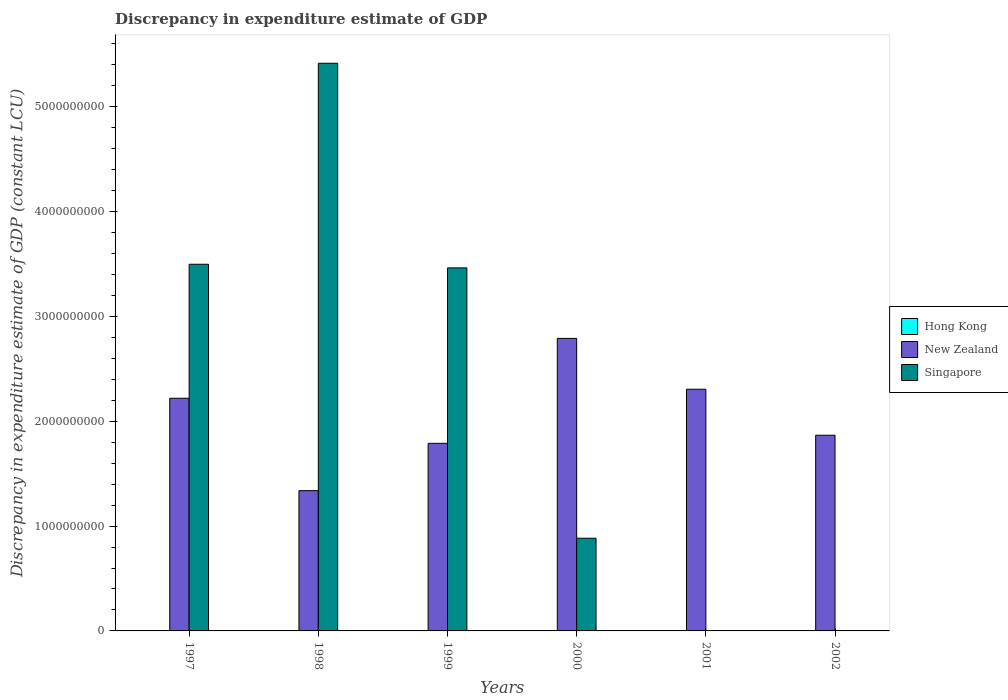How many different coloured bars are there?
Your answer should be very brief. 2. Are the number of bars per tick equal to the number of legend labels?
Your answer should be compact. No. How many bars are there on the 3rd tick from the right?
Your response must be concise. 2. What is the label of the 1st group of bars from the left?
Offer a very short reply. 1997. What is the discrepancy in expenditure estimate of GDP in Hong Kong in 2000?
Make the answer very short. 0. Across all years, what is the maximum discrepancy in expenditure estimate of GDP in Singapore?
Keep it short and to the point. 5.41e+09. Across all years, what is the minimum discrepancy in expenditure estimate of GDP in Singapore?
Ensure brevity in your answer.  0. In which year was the discrepancy in expenditure estimate of GDP in Singapore maximum?
Ensure brevity in your answer.  1998. What is the total discrepancy in expenditure estimate of GDP in Singapore in the graph?
Your answer should be compact. 1.33e+1. What is the difference between the discrepancy in expenditure estimate of GDP in New Zealand in 2001 and that in 2002?
Offer a very short reply. 4.39e+08. What is the difference between the discrepancy in expenditure estimate of GDP in Hong Kong in 1997 and the discrepancy in expenditure estimate of GDP in New Zealand in 2001?
Offer a very short reply. -2.30e+09. What is the average discrepancy in expenditure estimate of GDP in Hong Kong per year?
Offer a terse response. 0. In the year 1999, what is the difference between the discrepancy in expenditure estimate of GDP in Singapore and discrepancy in expenditure estimate of GDP in New Zealand?
Make the answer very short. 1.67e+09. What is the ratio of the discrepancy in expenditure estimate of GDP in Singapore in 1998 to that in 1999?
Keep it short and to the point. 1.56. Is the difference between the discrepancy in expenditure estimate of GDP in Singapore in 1998 and 1999 greater than the difference between the discrepancy in expenditure estimate of GDP in New Zealand in 1998 and 1999?
Your answer should be compact. Yes. What is the difference between the highest and the second highest discrepancy in expenditure estimate of GDP in Singapore?
Provide a short and direct response. 1.92e+09. What is the difference between the highest and the lowest discrepancy in expenditure estimate of GDP in Singapore?
Provide a succinct answer. 5.41e+09. Is the sum of the discrepancy in expenditure estimate of GDP in Singapore in 1998 and 2000 greater than the maximum discrepancy in expenditure estimate of GDP in New Zealand across all years?
Your answer should be very brief. Yes. How many bars are there?
Give a very brief answer. 10. How many years are there in the graph?
Your answer should be compact. 6. What is the difference between two consecutive major ticks on the Y-axis?
Offer a very short reply. 1.00e+09. Are the values on the major ticks of Y-axis written in scientific E-notation?
Your response must be concise. No. Does the graph contain any zero values?
Ensure brevity in your answer.  Yes. Does the graph contain grids?
Ensure brevity in your answer.  No. Where does the legend appear in the graph?
Your answer should be compact. Center right. How many legend labels are there?
Your answer should be compact. 3. How are the legend labels stacked?
Make the answer very short. Vertical. What is the title of the graph?
Give a very brief answer. Discrepancy in expenditure estimate of GDP. Does "Togo" appear as one of the legend labels in the graph?
Give a very brief answer. No. What is the label or title of the Y-axis?
Give a very brief answer. Discrepancy in expenditure estimate of GDP (constant LCU). What is the Discrepancy in expenditure estimate of GDP (constant LCU) in Hong Kong in 1997?
Your answer should be very brief. 0. What is the Discrepancy in expenditure estimate of GDP (constant LCU) of New Zealand in 1997?
Provide a short and direct response. 2.22e+09. What is the Discrepancy in expenditure estimate of GDP (constant LCU) in Singapore in 1997?
Ensure brevity in your answer.  3.50e+09. What is the Discrepancy in expenditure estimate of GDP (constant LCU) in New Zealand in 1998?
Give a very brief answer. 1.34e+09. What is the Discrepancy in expenditure estimate of GDP (constant LCU) of Singapore in 1998?
Give a very brief answer. 5.41e+09. What is the Discrepancy in expenditure estimate of GDP (constant LCU) in Hong Kong in 1999?
Your response must be concise. 0. What is the Discrepancy in expenditure estimate of GDP (constant LCU) of New Zealand in 1999?
Make the answer very short. 1.79e+09. What is the Discrepancy in expenditure estimate of GDP (constant LCU) in Singapore in 1999?
Give a very brief answer. 3.46e+09. What is the Discrepancy in expenditure estimate of GDP (constant LCU) in New Zealand in 2000?
Make the answer very short. 2.79e+09. What is the Discrepancy in expenditure estimate of GDP (constant LCU) of Singapore in 2000?
Your answer should be compact. 8.84e+08. What is the Discrepancy in expenditure estimate of GDP (constant LCU) in New Zealand in 2001?
Your response must be concise. 2.30e+09. What is the Discrepancy in expenditure estimate of GDP (constant LCU) of New Zealand in 2002?
Offer a terse response. 1.87e+09. What is the Discrepancy in expenditure estimate of GDP (constant LCU) of Singapore in 2002?
Provide a short and direct response. 0. Across all years, what is the maximum Discrepancy in expenditure estimate of GDP (constant LCU) in New Zealand?
Your answer should be very brief. 2.79e+09. Across all years, what is the maximum Discrepancy in expenditure estimate of GDP (constant LCU) of Singapore?
Provide a short and direct response. 5.41e+09. Across all years, what is the minimum Discrepancy in expenditure estimate of GDP (constant LCU) in New Zealand?
Ensure brevity in your answer.  1.34e+09. Across all years, what is the minimum Discrepancy in expenditure estimate of GDP (constant LCU) of Singapore?
Make the answer very short. 0. What is the total Discrepancy in expenditure estimate of GDP (constant LCU) of New Zealand in the graph?
Offer a very short reply. 1.23e+1. What is the total Discrepancy in expenditure estimate of GDP (constant LCU) of Singapore in the graph?
Your answer should be compact. 1.33e+1. What is the difference between the Discrepancy in expenditure estimate of GDP (constant LCU) in New Zealand in 1997 and that in 1998?
Your answer should be compact. 8.81e+08. What is the difference between the Discrepancy in expenditure estimate of GDP (constant LCU) in Singapore in 1997 and that in 1998?
Provide a succinct answer. -1.92e+09. What is the difference between the Discrepancy in expenditure estimate of GDP (constant LCU) in New Zealand in 1997 and that in 1999?
Make the answer very short. 4.30e+08. What is the difference between the Discrepancy in expenditure estimate of GDP (constant LCU) in Singapore in 1997 and that in 1999?
Offer a terse response. 3.47e+07. What is the difference between the Discrepancy in expenditure estimate of GDP (constant LCU) in New Zealand in 1997 and that in 2000?
Give a very brief answer. -5.71e+08. What is the difference between the Discrepancy in expenditure estimate of GDP (constant LCU) in Singapore in 1997 and that in 2000?
Your answer should be compact. 2.61e+09. What is the difference between the Discrepancy in expenditure estimate of GDP (constant LCU) of New Zealand in 1997 and that in 2001?
Offer a terse response. -8.61e+07. What is the difference between the Discrepancy in expenditure estimate of GDP (constant LCU) of New Zealand in 1997 and that in 2002?
Ensure brevity in your answer.  3.53e+08. What is the difference between the Discrepancy in expenditure estimate of GDP (constant LCU) of New Zealand in 1998 and that in 1999?
Offer a very short reply. -4.51e+08. What is the difference between the Discrepancy in expenditure estimate of GDP (constant LCU) in Singapore in 1998 and that in 1999?
Your response must be concise. 1.95e+09. What is the difference between the Discrepancy in expenditure estimate of GDP (constant LCU) in New Zealand in 1998 and that in 2000?
Make the answer very short. -1.45e+09. What is the difference between the Discrepancy in expenditure estimate of GDP (constant LCU) in Singapore in 1998 and that in 2000?
Make the answer very short. 4.53e+09. What is the difference between the Discrepancy in expenditure estimate of GDP (constant LCU) in New Zealand in 1998 and that in 2001?
Your answer should be very brief. -9.67e+08. What is the difference between the Discrepancy in expenditure estimate of GDP (constant LCU) of New Zealand in 1998 and that in 2002?
Your answer should be very brief. -5.28e+08. What is the difference between the Discrepancy in expenditure estimate of GDP (constant LCU) in New Zealand in 1999 and that in 2000?
Provide a short and direct response. -1.00e+09. What is the difference between the Discrepancy in expenditure estimate of GDP (constant LCU) in Singapore in 1999 and that in 2000?
Keep it short and to the point. 2.58e+09. What is the difference between the Discrepancy in expenditure estimate of GDP (constant LCU) in New Zealand in 1999 and that in 2001?
Offer a very short reply. -5.16e+08. What is the difference between the Discrepancy in expenditure estimate of GDP (constant LCU) in New Zealand in 1999 and that in 2002?
Your answer should be compact. -7.74e+07. What is the difference between the Discrepancy in expenditure estimate of GDP (constant LCU) of New Zealand in 2000 and that in 2001?
Offer a terse response. 4.85e+08. What is the difference between the Discrepancy in expenditure estimate of GDP (constant LCU) in New Zealand in 2000 and that in 2002?
Provide a succinct answer. 9.23e+08. What is the difference between the Discrepancy in expenditure estimate of GDP (constant LCU) in New Zealand in 2001 and that in 2002?
Your answer should be compact. 4.39e+08. What is the difference between the Discrepancy in expenditure estimate of GDP (constant LCU) in New Zealand in 1997 and the Discrepancy in expenditure estimate of GDP (constant LCU) in Singapore in 1998?
Provide a succinct answer. -3.19e+09. What is the difference between the Discrepancy in expenditure estimate of GDP (constant LCU) in New Zealand in 1997 and the Discrepancy in expenditure estimate of GDP (constant LCU) in Singapore in 1999?
Provide a succinct answer. -1.24e+09. What is the difference between the Discrepancy in expenditure estimate of GDP (constant LCU) of New Zealand in 1997 and the Discrepancy in expenditure estimate of GDP (constant LCU) of Singapore in 2000?
Your answer should be very brief. 1.34e+09. What is the difference between the Discrepancy in expenditure estimate of GDP (constant LCU) in New Zealand in 1998 and the Discrepancy in expenditure estimate of GDP (constant LCU) in Singapore in 1999?
Make the answer very short. -2.12e+09. What is the difference between the Discrepancy in expenditure estimate of GDP (constant LCU) in New Zealand in 1998 and the Discrepancy in expenditure estimate of GDP (constant LCU) in Singapore in 2000?
Offer a terse response. 4.54e+08. What is the difference between the Discrepancy in expenditure estimate of GDP (constant LCU) of New Zealand in 1999 and the Discrepancy in expenditure estimate of GDP (constant LCU) of Singapore in 2000?
Keep it short and to the point. 9.05e+08. What is the average Discrepancy in expenditure estimate of GDP (constant LCU) of New Zealand per year?
Keep it short and to the point. 2.05e+09. What is the average Discrepancy in expenditure estimate of GDP (constant LCU) in Singapore per year?
Offer a terse response. 2.21e+09. In the year 1997, what is the difference between the Discrepancy in expenditure estimate of GDP (constant LCU) of New Zealand and Discrepancy in expenditure estimate of GDP (constant LCU) of Singapore?
Make the answer very short. -1.28e+09. In the year 1998, what is the difference between the Discrepancy in expenditure estimate of GDP (constant LCU) in New Zealand and Discrepancy in expenditure estimate of GDP (constant LCU) in Singapore?
Keep it short and to the point. -4.08e+09. In the year 1999, what is the difference between the Discrepancy in expenditure estimate of GDP (constant LCU) of New Zealand and Discrepancy in expenditure estimate of GDP (constant LCU) of Singapore?
Ensure brevity in your answer.  -1.67e+09. In the year 2000, what is the difference between the Discrepancy in expenditure estimate of GDP (constant LCU) in New Zealand and Discrepancy in expenditure estimate of GDP (constant LCU) in Singapore?
Ensure brevity in your answer.  1.91e+09. What is the ratio of the Discrepancy in expenditure estimate of GDP (constant LCU) of New Zealand in 1997 to that in 1998?
Give a very brief answer. 1.66. What is the ratio of the Discrepancy in expenditure estimate of GDP (constant LCU) of Singapore in 1997 to that in 1998?
Keep it short and to the point. 0.65. What is the ratio of the Discrepancy in expenditure estimate of GDP (constant LCU) in New Zealand in 1997 to that in 1999?
Provide a short and direct response. 1.24. What is the ratio of the Discrepancy in expenditure estimate of GDP (constant LCU) of Singapore in 1997 to that in 1999?
Your answer should be compact. 1.01. What is the ratio of the Discrepancy in expenditure estimate of GDP (constant LCU) of New Zealand in 1997 to that in 2000?
Make the answer very short. 0.8. What is the ratio of the Discrepancy in expenditure estimate of GDP (constant LCU) in Singapore in 1997 to that in 2000?
Give a very brief answer. 3.96. What is the ratio of the Discrepancy in expenditure estimate of GDP (constant LCU) in New Zealand in 1997 to that in 2001?
Ensure brevity in your answer.  0.96. What is the ratio of the Discrepancy in expenditure estimate of GDP (constant LCU) of New Zealand in 1997 to that in 2002?
Make the answer very short. 1.19. What is the ratio of the Discrepancy in expenditure estimate of GDP (constant LCU) in New Zealand in 1998 to that in 1999?
Give a very brief answer. 0.75. What is the ratio of the Discrepancy in expenditure estimate of GDP (constant LCU) of Singapore in 1998 to that in 1999?
Offer a terse response. 1.56. What is the ratio of the Discrepancy in expenditure estimate of GDP (constant LCU) of New Zealand in 1998 to that in 2000?
Offer a terse response. 0.48. What is the ratio of the Discrepancy in expenditure estimate of GDP (constant LCU) of Singapore in 1998 to that in 2000?
Your response must be concise. 6.13. What is the ratio of the Discrepancy in expenditure estimate of GDP (constant LCU) of New Zealand in 1998 to that in 2001?
Make the answer very short. 0.58. What is the ratio of the Discrepancy in expenditure estimate of GDP (constant LCU) in New Zealand in 1998 to that in 2002?
Your answer should be very brief. 0.72. What is the ratio of the Discrepancy in expenditure estimate of GDP (constant LCU) of New Zealand in 1999 to that in 2000?
Provide a succinct answer. 0.64. What is the ratio of the Discrepancy in expenditure estimate of GDP (constant LCU) of Singapore in 1999 to that in 2000?
Provide a short and direct response. 3.92. What is the ratio of the Discrepancy in expenditure estimate of GDP (constant LCU) in New Zealand in 1999 to that in 2001?
Make the answer very short. 0.78. What is the ratio of the Discrepancy in expenditure estimate of GDP (constant LCU) of New Zealand in 1999 to that in 2002?
Your answer should be compact. 0.96. What is the ratio of the Discrepancy in expenditure estimate of GDP (constant LCU) of New Zealand in 2000 to that in 2001?
Your answer should be very brief. 1.21. What is the ratio of the Discrepancy in expenditure estimate of GDP (constant LCU) of New Zealand in 2000 to that in 2002?
Your response must be concise. 1.49. What is the ratio of the Discrepancy in expenditure estimate of GDP (constant LCU) of New Zealand in 2001 to that in 2002?
Your answer should be very brief. 1.24. What is the difference between the highest and the second highest Discrepancy in expenditure estimate of GDP (constant LCU) of New Zealand?
Keep it short and to the point. 4.85e+08. What is the difference between the highest and the second highest Discrepancy in expenditure estimate of GDP (constant LCU) in Singapore?
Your answer should be very brief. 1.92e+09. What is the difference between the highest and the lowest Discrepancy in expenditure estimate of GDP (constant LCU) in New Zealand?
Provide a succinct answer. 1.45e+09. What is the difference between the highest and the lowest Discrepancy in expenditure estimate of GDP (constant LCU) in Singapore?
Offer a very short reply. 5.41e+09. 